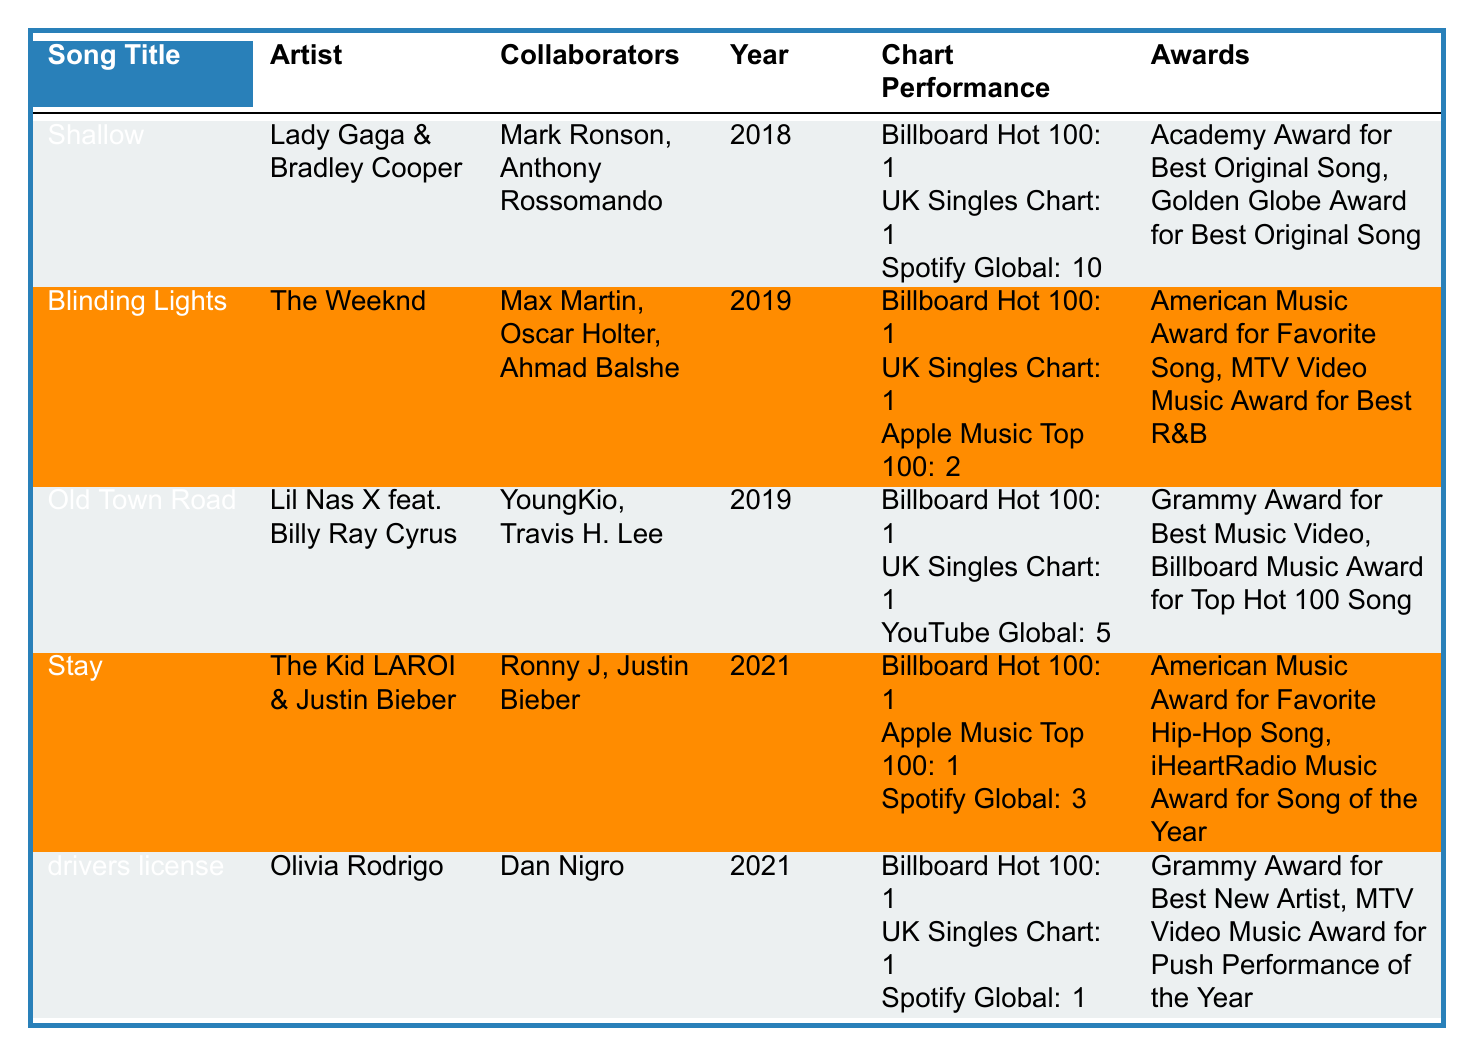What is the song with the most collaborators? In the table, "Blinding Lights" has three collaborators: Max Martin, Oscar Holter, and Ahmad Balshe. All other songs have either one or two collaborators.
Answer: Blinding Lights Which song was released in 2021 and topped the Billboard Hot 100? "drivers license" and "Stay" are both songs released in 2021 that reached number one on the Billboard Hot 100.
Answer: drivers license and Stay Did any song win an award for Best Original Song? "Shallow" won the Academy Award and Golden Globe for Best Original Song.
Answer: Yes What is the average chart position of "Shallow" across the Billboard Hot 100, UK Singles Chart, and Spotify Global? For "Shallow": Billboard Hot 100: 1, UK Singles Chart: 1, Spotify Global: 10. The average is (1 + 1 + 10) / 3 = 4.
Answer: 4 Which song had the highest ranking on the Spotify Global chart? "drivers license" ranks 1st on the Spotify Global chart, while "Shallow" ranks 10th, "Stay" ranks 3rd, and others rank lower.
Answer: drivers license How many songs have won a Grammy Award? From the table, "drivers license" won a Grammy Award for Best New Artist and "Old Town Road" won a Grammy for Best Music Video, indicating two songs won Grammy Awards.
Answer: 2 Which song has the lowest position on the Spotify Global chart? "Shallow" has the lowest position at 10 on the Spotify Global chart, compared to other songs listed.
Answer: Shallow Has any song collaborated with both its main artist and another collaborator? Yes, "Stay" has Justin Bieber listed as both the main artist and a collaborator.
Answer: Yes What is the total number of awards won by the song "Old Town Road"? "Old Town Road" has two awards listed: the Grammy Award for Best Music Video and the Billboard Music Award for Top Hot 100 Song. Therefore, it has a total of 2 awards.
Answer: 2 Which year had the highest number of chart-topping songs? 2019 had three songs ("Blinding Lights," "Old Town Road") that topped charts, while 2018 and 2021 had one song each, making 2019 the year with the most chart-toppers.
Answer: 2019 